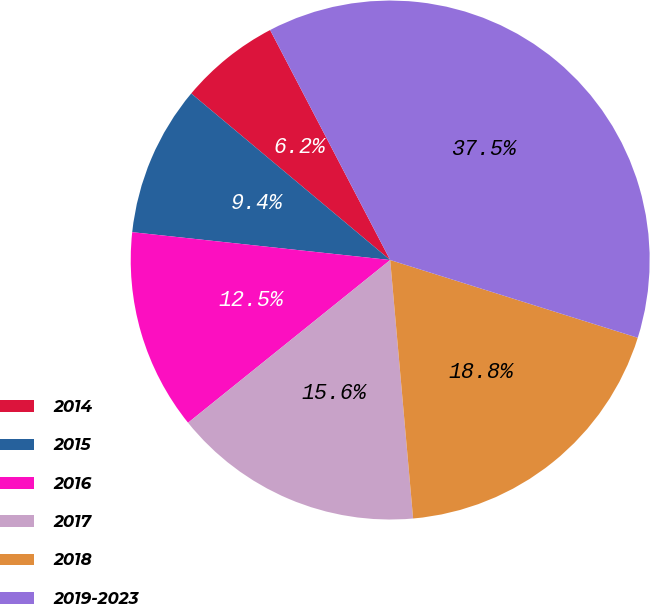<chart> <loc_0><loc_0><loc_500><loc_500><pie_chart><fcel>2014<fcel>2015<fcel>2016<fcel>2017<fcel>2018<fcel>2019-2023<nl><fcel>6.25%<fcel>9.38%<fcel>12.5%<fcel>15.62%<fcel>18.75%<fcel>37.5%<nl></chart> 